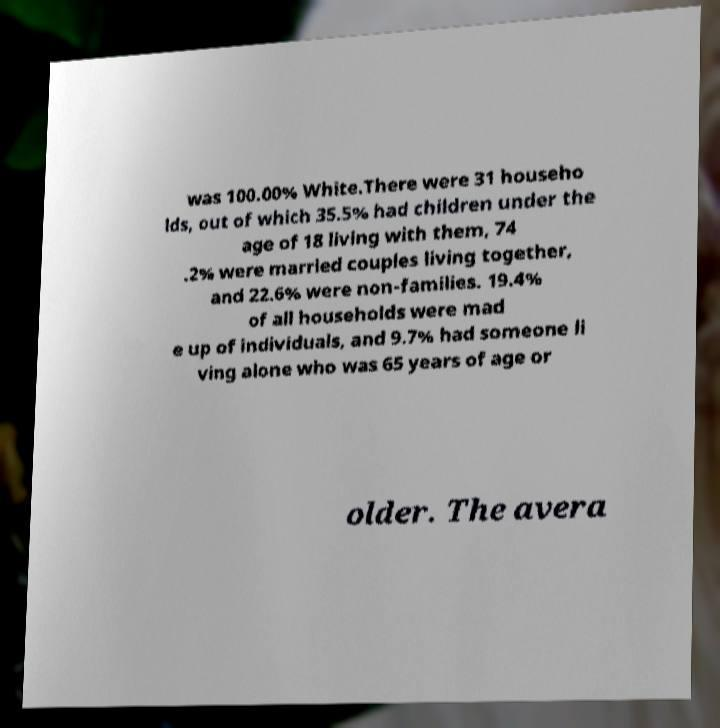Please identify and transcribe the text found in this image. was 100.00% White.There were 31 househo lds, out of which 35.5% had children under the age of 18 living with them, 74 .2% were married couples living together, and 22.6% were non-families. 19.4% of all households were mad e up of individuals, and 9.7% had someone li ving alone who was 65 years of age or older. The avera 